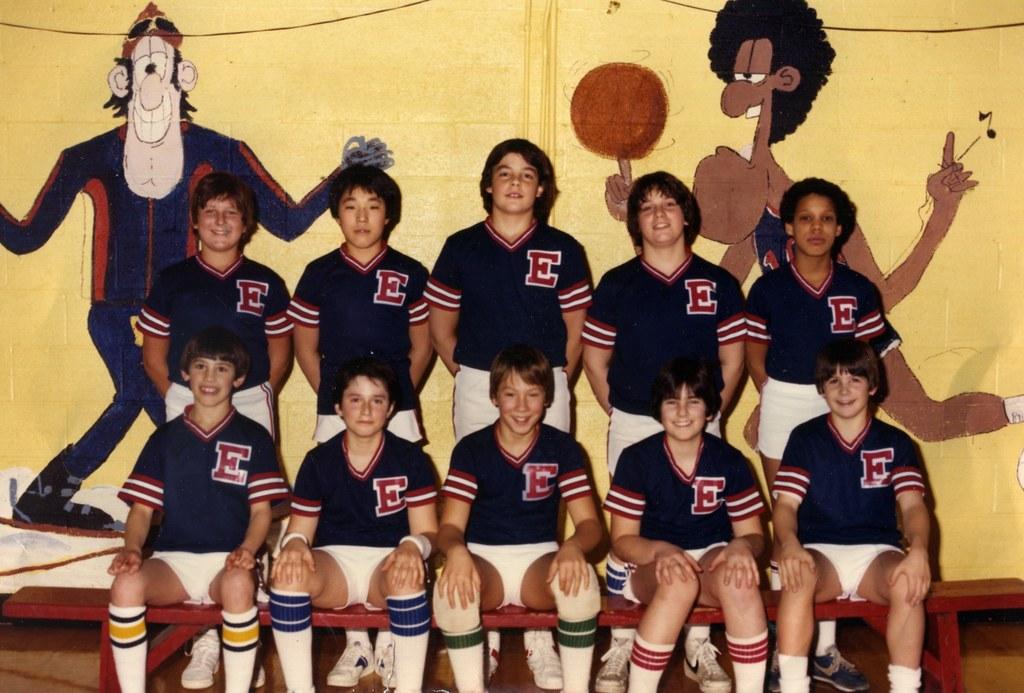What letter is on all their shirts?
Keep it short and to the point. E. 